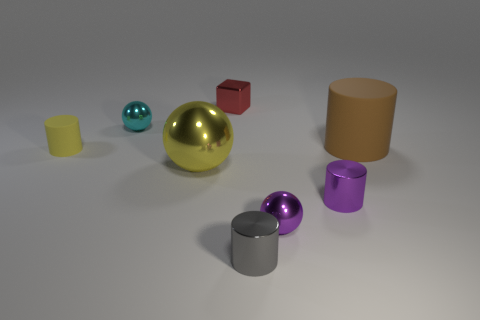Is the tiny gray thing made of the same material as the large sphere?
Your response must be concise. Yes. There is a tiny shiny sphere that is behind the purple metallic ball; is there a tiny cyan metal object on the left side of it?
Your answer should be very brief. No. Are there any small red metallic objects that have the same shape as the gray object?
Keep it short and to the point. No. Is the color of the big cylinder the same as the tiny matte cylinder?
Give a very brief answer. No. What is the small ball in front of the matte object left of the large metal object made of?
Ensure brevity in your answer.  Metal. The gray cylinder has what size?
Ensure brevity in your answer.  Small. There is a gray cylinder that is made of the same material as the small cube; what size is it?
Make the answer very short. Small. Does the shiny object that is behind the cyan shiny thing have the same size as the large ball?
Ensure brevity in your answer.  No. There is a yellow rubber object that is in front of the object that is behind the small metallic sphere behind the big brown matte thing; what is its shape?
Keep it short and to the point. Cylinder. How many things are rubber objects or tiny cylinders to the right of the cyan thing?
Provide a short and direct response. 4. 